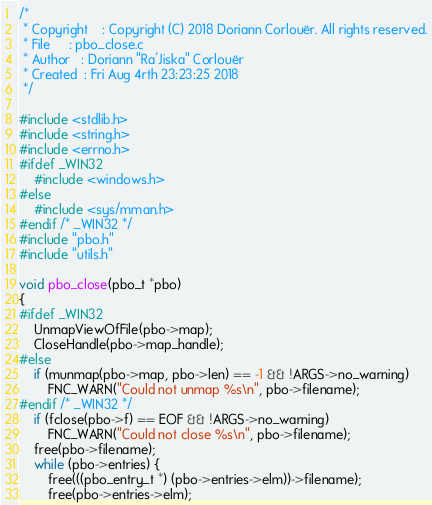Convert code to text. <code><loc_0><loc_0><loc_500><loc_500><_C_>/*
 * Copyright	: Copyright (C) 2018 Doriann Corlouër. All rights reserved.
 * File		: pbo_close.c
 * Author	: Doriann "Ra'Jiska" Corlouër
 * Created	: Fri Aug 4rth 23:23:25 2018
 */

#include <stdlib.h>
#include <string.h>
#include <errno.h>
#ifdef _WIN32
	#include <windows.h>
#else
	#include <sys/mman.h>
#endif /* _WIN32 */
#include "pbo.h"
#include "utils.h"

void pbo_close(pbo_t *pbo)
{
#ifdef _WIN32
	UnmapViewOfFile(pbo->map);
	CloseHandle(pbo->map_handle);
#else
	if (munmap(pbo->map, pbo->len) == -1 && !ARGS->no_warning)
		FNC_WARN("Could not unmap %s\n", pbo->filename);
#endif /* _WIN32 */
	if (fclose(pbo->f) == EOF && !ARGS->no_warning)
		FNC_WARN("Could not close %s\n", pbo->filename);
	free(pbo->filename);
	while (pbo->entries) {
		free(((pbo_entry_t *) (pbo->entries->elm))->filename);
		free(pbo->entries->elm);</code> 